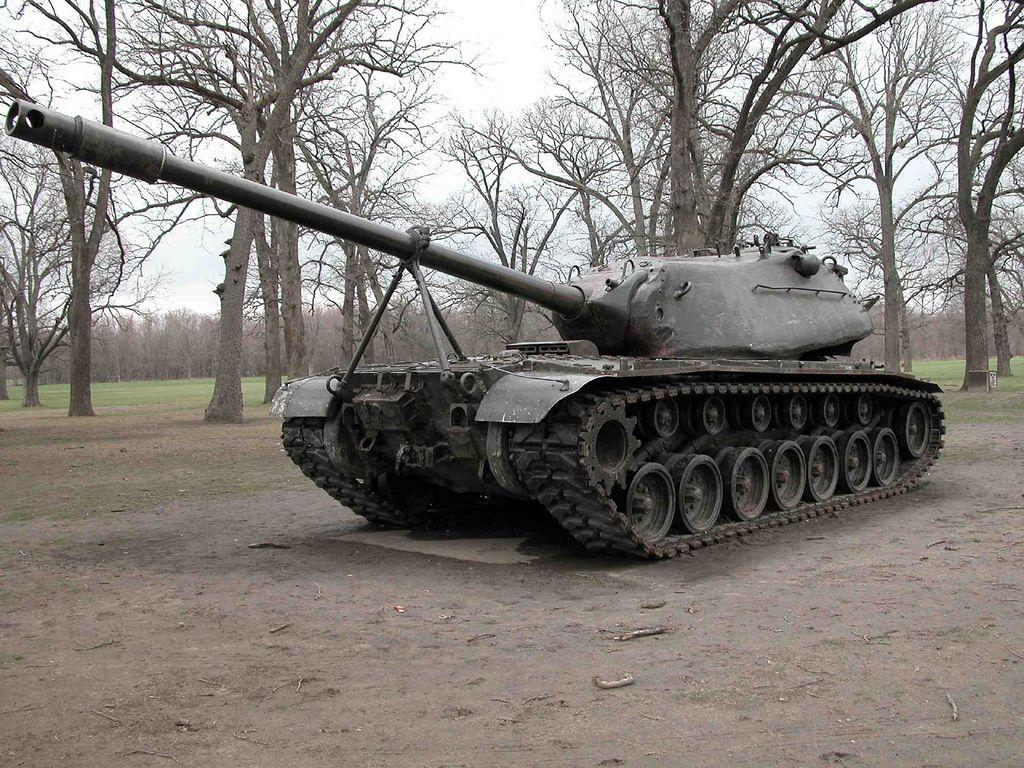What is the main subject of the image? The main subject of the image is a military tanker. Where is the military tanker located in the image? The military tanker is on the ground in the image. What can be seen in the background of the image? There are tall trees in the background of the image. What type of terrain is visible at the bottom of the image? There is soil visible at the bottom of the image. Where is the playground located in the image? There is no playground present in the image. What type of competition is taking place in the image? There is no competition present in the image. 